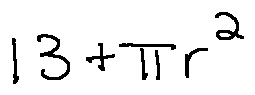Convert formula to latex. <formula><loc_0><loc_0><loc_500><loc_500>1 3 + \pi r ^ { 2 }</formula> 